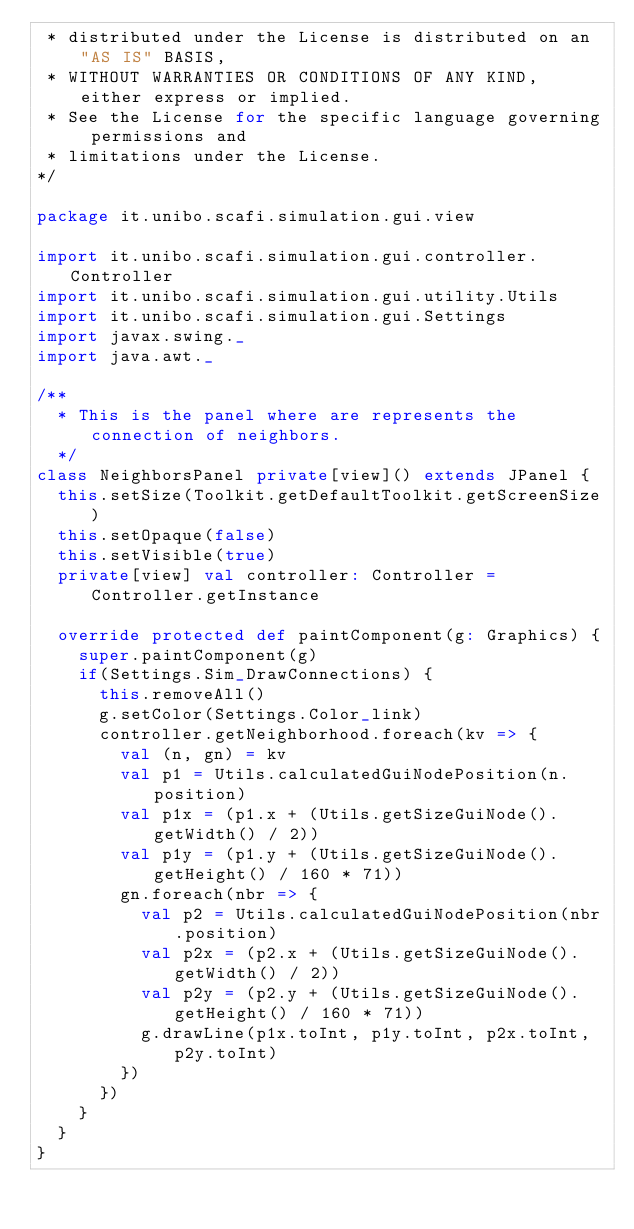Convert code to text. <code><loc_0><loc_0><loc_500><loc_500><_Scala_> * distributed under the License is distributed on an "AS IS" BASIS,
 * WITHOUT WARRANTIES OR CONDITIONS OF ANY KIND, either express or implied.
 * See the License for the specific language governing permissions and
 * limitations under the License.
*/

package it.unibo.scafi.simulation.gui.view

import it.unibo.scafi.simulation.gui.controller.Controller
import it.unibo.scafi.simulation.gui.utility.Utils
import it.unibo.scafi.simulation.gui.Settings
import javax.swing._
import java.awt._

/**
  * This is the panel where are represents the connection of neighbors.
  */
class NeighborsPanel private[view]() extends JPanel {
  this.setSize(Toolkit.getDefaultToolkit.getScreenSize)
  this.setOpaque(false)
  this.setVisible(true)
  private[view] val controller: Controller = Controller.getInstance

  override protected def paintComponent(g: Graphics) {
    super.paintComponent(g)
    if(Settings.Sim_DrawConnections) {
      this.removeAll()
      g.setColor(Settings.Color_link)
      controller.getNeighborhood.foreach(kv => {
        val (n, gn) = kv
        val p1 = Utils.calculatedGuiNodePosition(n.position)
        val p1x = (p1.x + (Utils.getSizeGuiNode().getWidth() / 2))
        val p1y = (p1.y + (Utils.getSizeGuiNode().getHeight() / 160 * 71))
        gn.foreach(nbr => {
          val p2 = Utils.calculatedGuiNodePosition(nbr.position)
          val p2x = (p2.x + (Utils.getSizeGuiNode().getWidth() / 2))
          val p2y = (p2.y + (Utils.getSizeGuiNode().getHeight() / 160 * 71))
          g.drawLine(p1x.toInt, p1y.toInt, p2x.toInt, p2y.toInt)
        })
      })
    }
  }
}
</code> 